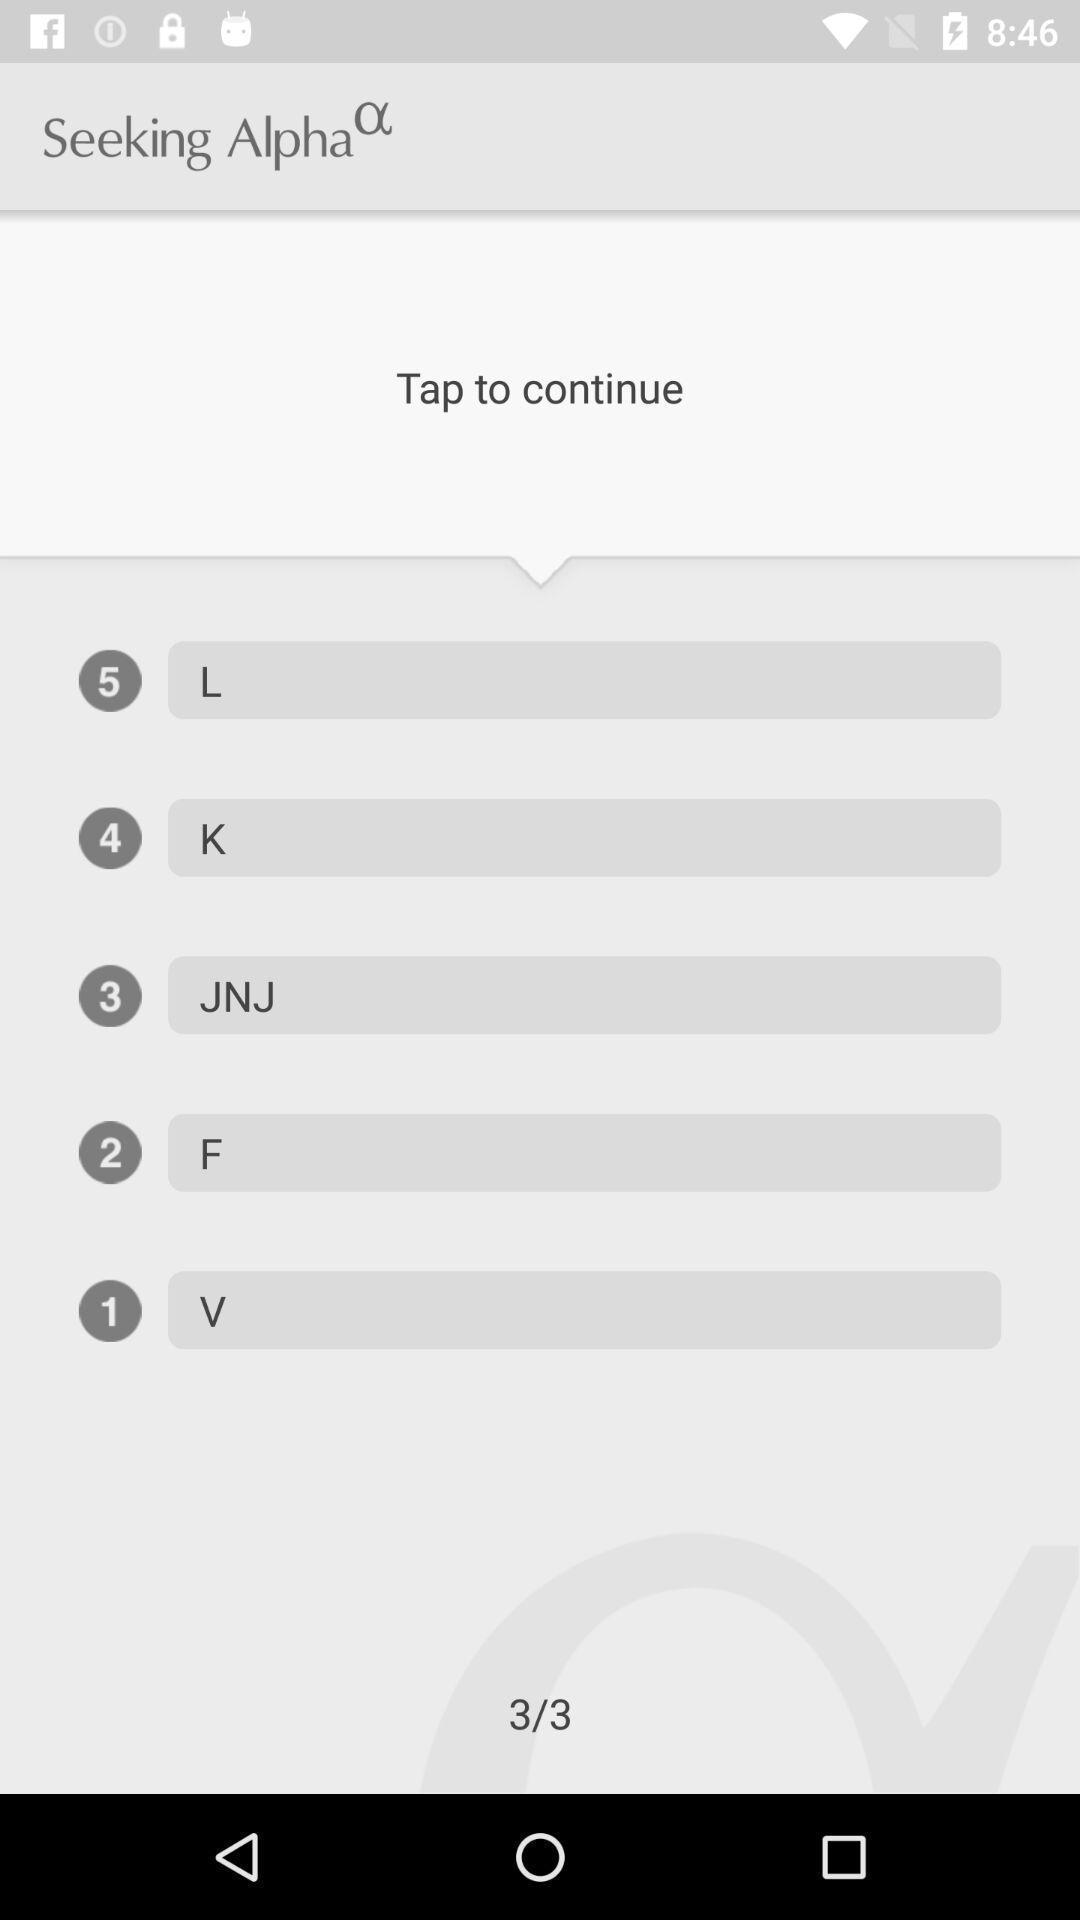Summarize the information in this screenshot. Page showing options to continue in learning app. 